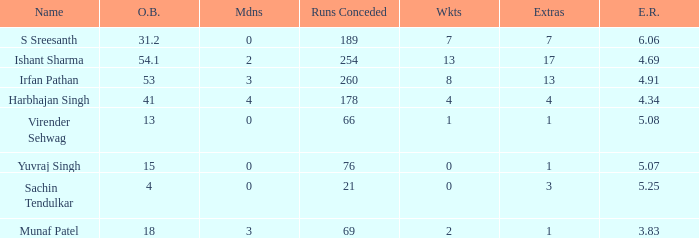How many wickets are there for 15 overs bowled? 0.0. 